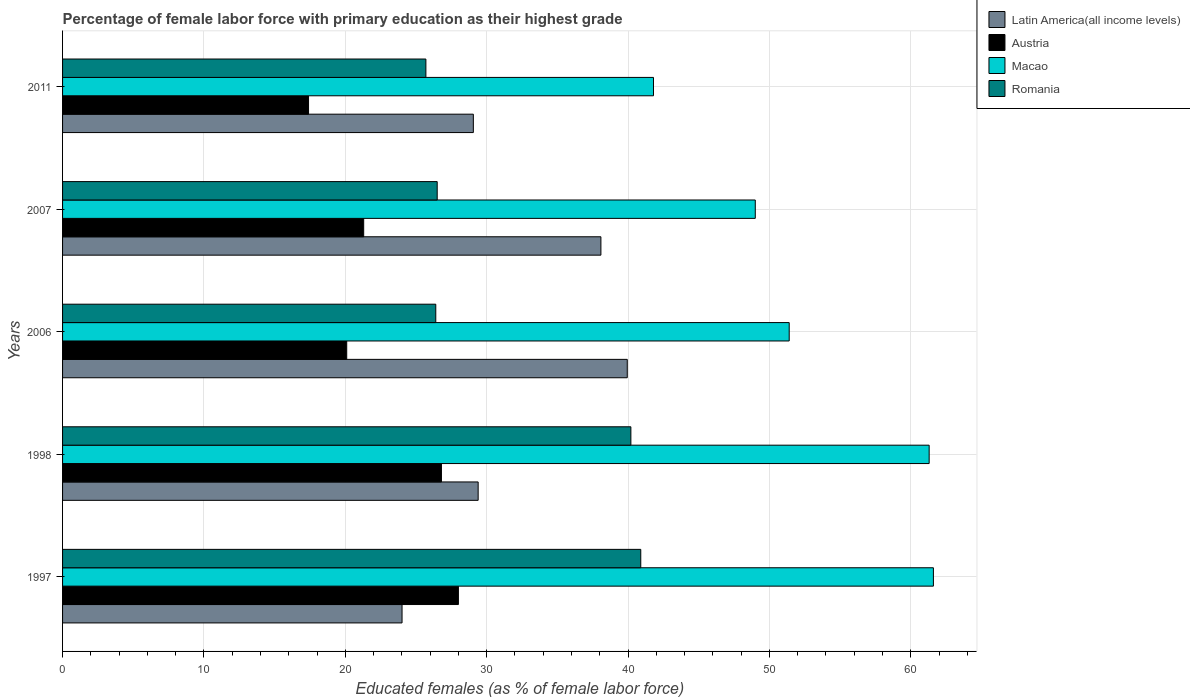Are the number of bars per tick equal to the number of legend labels?
Make the answer very short. Yes. Are the number of bars on each tick of the Y-axis equal?
Offer a terse response. Yes. How many bars are there on the 2nd tick from the bottom?
Make the answer very short. 4. What is the label of the 3rd group of bars from the top?
Keep it short and to the point. 2006. In how many cases, is the number of bars for a given year not equal to the number of legend labels?
Provide a succinct answer. 0. What is the percentage of female labor force with primary education in Austria in 1997?
Your response must be concise. 28. Across all years, what is the maximum percentage of female labor force with primary education in Latin America(all income levels)?
Provide a short and direct response. 39.95. Across all years, what is the minimum percentage of female labor force with primary education in Macao?
Keep it short and to the point. 41.8. What is the total percentage of female labor force with primary education in Macao in the graph?
Your response must be concise. 265.1. What is the difference between the percentage of female labor force with primary education in Macao in 1998 and that in 2006?
Provide a succinct answer. 9.9. What is the difference between the percentage of female labor force with primary education in Latin America(all income levels) in 2011 and the percentage of female labor force with primary education in Romania in 1997?
Provide a succinct answer. -11.84. What is the average percentage of female labor force with primary education in Macao per year?
Your response must be concise. 53.02. In the year 1997, what is the difference between the percentage of female labor force with primary education in Austria and percentage of female labor force with primary education in Latin America(all income levels)?
Provide a short and direct response. 3.99. What is the ratio of the percentage of female labor force with primary education in Austria in 2007 to that in 2011?
Provide a succinct answer. 1.22. Is the percentage of female labor force with primary education in Macao in 1997 less than that in 2006?
Your answer should be very brief. No. Is the difference between the percentage of female labor force with primary education in Austria in 1998 and 2006 greater than the difference between the percentage of female labor force with primary education in Latin America(all income levels) in 1998 and 2006?
Provide a short and direct response. Yes. What is the difference between the highest and the second highest percentage of female labor force with primary education in Latin America(all income levels)?
Offer a very short reply. 1.87. What is the difference between the highest and the lowest percentage of female labor force with primary education in Austria?
Ensure brevity in your answer.  10.6. What does the 2nd bar from the top in 2007 represents?
Provide a short and direct response. Macao. What does the 1st bar from the bottom in 2006 represents?
Offer a very short reply. Latin America(all income levels). Is it the case that in every year, the sum of the percentage of female labor force with primary education in Macao and percentage of female labor force with primary education in Romania is greater than the percentage of female labor force with primary education in Latin America(all income levels)?
Offer a very short reply. Yes. How many bars are there?
Your answer should be very brief. 20. Are all the bars in the graph horizontal?
Keep it short and to the point. Yes. How many years are there in the graph?
Your answer should be compact. 5. What is the difference between two consecutive major ticks on the X-axis?
Your answer should be very brief. 10. Does the graph contain any zero values?
Make the answer very short. No. Does the graph contain grids?
Your answer should be compact. Yes. Where does the legend appear in the graph?
Your answer should be compact. Top right. How are the legend labels stacked?
Your response must be concise. Vertical. What is the title of the graph?
Offer a terse response. Percentage of female labor force with primary education as their highest grade. Does "Paraguay" appear as one of the legend labels in the graph?
Give a very brief answer. No. What is the label or title of the X-axis?
Ensure brevity in your answer.  Educated females (as % of female labor force). What is the label or title of the Y-axis?
Give a very brief answer. Years. What is the Educated females (as % of female labor force) of Latin America(all income levels) in 1997?
Give a very brief answer. 24.01. What is the Educated females (as % of female labor force) in Macao in 1997?
Offer a very short reply. 61.6. What is the Educated females (as % of female labor force) in Romania in 1997?
Keep it short and to the point. 40.9. What is the Educated females (as % of female labor force) of Latin America(all income levels) in 1998?
Provide a succinct answer. 29.4. What is the Educated females (as % of female labor force) of Austria in 1998?
Provide a succinct answer. 26.8. What is the Educated females (as % of female labor force) in Macao in 1998?
Ensure brevity in your answer.  61.3. What is the Educated females (as % of female labor force) in Romania in 1998?
Your response must be concise. 40.2. What is the Educated females (as % of female labor force) of Latin America(all income levels) in 2006?
Your response must be concise. 39.95. What is the Educated females (as % of female labor force) in Austria in 2006?
Give a very brief answer. 20.1. What is the Educated females (as % of female labor force) of Macao in 2006?
Your response must be concise. 51.4. What is the Educated females (as % of female labor force) of Romania in 2006?
Keep it short and to the point. 26.4. What is the Educated females (as % of female labor force) of Latin America(all income levels) in 2007?
Give a very brief answer. 38.08. What is the Educated females (as % of female labor force) in Austria in 2007?
Provide a succinct answer. 21.3. What is the Educated females (as % of female labor force) of Macao in 2007?
Give a very brief answer. 49. What is the Educated females (as % of female labor force) of Latin America(all income levels) in 2011?
Ensure brevity in your answer.  29.06. What is the Educated females (as % of female labor force) in Austria in 2011?
Make the answer very short. 17.4. What is the Educated females (as % of female labor force) in Macao in 2011?
Offer a terse response. 41.8. What is the Educated females (as % of female labor force) of Romania in 2011?
Your answer should be compact. 25.7. Across all years, what is the maximum Educated females (as % of female labor force) of Latin America(all income levels)?
Keep it short and to the point. 39.95. Across all years, what is the maximum Educated females (as % of female labor force) in Austria?
Offer a very short reply. 28. Across all years, what is the maximum Educated females (as % of female labor force) in Macao?
Make the answer very short. 61.6. Across all years, what is the maximum Educated females (as % of female labor force) of Romania?
Ensure brevity in your answer.  40.9. Across all years, what is the minimum Educated females (as % of female labor force) in Latin America(all income levels)?
Give a very brief answer. 24.01. Across all years, what is the minimum Educated females (as % of female labor force) of Austria?
Provide a short and direct response. 17.4. Across all years, what is the minimum Educated females (as % of female labor force) of Macao?
Give a very brief answer. 41.8. Across all years, what is the minimum Educated females (as % of female labor force) in Romania?
Offer a terse response. 25.7. What is the total Educated females (as % of female labor force) in Latin America(all income levels) in the graph?
Make the answer very short. 160.49. What is the total Educated females (as % of female labor force) of Austria in the graph?
Your response must be concise. 113.6. What is the total Educated females (as % of female labor force) in Macao in the graph?
Provide a succinct answer. 265.1. What is the total Educated females (as % of female labor force) in Romania in the graph?
Offer a terse response. 159.7. What is the difference between the Educated females (as % of female labor force) of Latin America(all income levels) in 1997 and that in 1998?
Ensure brevity in your answer.  -5.38. What is the difference between the Educated females (as % of female labor force) in Macao in 1997 and that in 1998?
Ensure brevity in your answer.  0.3. What is the difference between the Educated females (as % of female labor force) in Romania in 1997 and that in 1998?
Offer a terse response. 0.7. What is the difference between the Educated females (as % of female labor force) in Latin America(all income levels) in 1997 and that in 2006?
Ensure brevity in your answer.  -15.93. What is the difference between the Educated females (as % of female labor force) of Macao in 1997 and that in 2006?
Offer a very short reply. 10.2. What is the difference between the Educated females (as % of female labor force) in Romania in 1997 and that in 2006?
Make the answer very short. 14.5. What is the difference between the Educated females (as % of female labor force) in Latin America(all income levels) in 1997 and that in 2007?
Make the answer very short. -14.07. What is the difference between the Educated females (as % of female labor force) in Austria in 1997 and that in 2007?
Your answer should be very brief. 6.7. What is the difference between the Educated females (as % of female labor force) of Romania in 1997 and that in 2007?
Make the answer very short. 14.4. What is the difference between the Educated females (as % of female labor force) in Latin America(all income levels) in 1997 and that in 2011?
Keep it short and to the point. -5.04. What is the difference between the Educated females (as % of female labor force) in Austria in 1997 and that in 2011?
Provide a short and direct response. 10.6. What is the difference between the Educated females (as % of female labor force) of Macao in 1997 and that in 2011?
Ensure brevity in your answer.  19.8. What is the difference between the Educated females (as % of female labor force) of Latin America(all income levels) in 1998 and that in 2006?
Ensure brevity in your answer.  -10.55. What is the difference between the Educated females (as % of female labor force) in Macao in 1998 and that in 2006?
Your answer should be very brief. 9.9. What is the difference between the Educated females (as % of female labor force) in Romania in 1998 and that in 2006?
Your answer should be compact. 13.8. What is the difference between the Educated females (as % of female labor force) in Latin America(all income levels) in 1998 and that in 2007?
Make the answer very short. -8.68. What is the difference between the Educated females (as % of female labor force) in Austria in 1998 and that in 2007?
Ensure brevity in your answer.  5.5. What is the difference between the Educated females (as % of female labor force) in Macao in 1998 and that in 2007?
Provide a short and direct response. 12.3. What is the difference between the Educated females (as % of female labor force) of Romania in 1998 and that in 2007?
Keep it short and to the point. 13.7. What is the difference between the Educated females (as % of female labor force) in Latin America(all income levels) in 1998 and that in 2011?
Your response must be concise. 0.34. What is the difference between the Educated females (as % of female labor force) in Austria in 1998 and that in 2011?
Keep it short and to the point. 9.4. What is the difference between the Educated females (as % of female labor force) of Macao in 1998 and that in 2011?
Your answer should be compact. 19.5. What is the difference between the Educated females (as % of female labor force) of Latin America(all income levels) in 2006 and that in 2007?
Give a very brief answer. 1.87. What is the difference between the Educated females (as % of female labor force) in Austria in 2006 and that in 2007?
Provide a succinct answer. -1.2. What is the difference between the Educated females (as % of female labor force) of Macao in 2006 and that in 2007?
Your response must be concise. 2.4. What is the difference between the Educated females (as % of female labor force) in Latin America(all income levels) in 2006 and that in 2011?
Your answer should be very brief. 10.89. What is the difference between the Educated females (as % of female labor force) of Austria in 2006 and that in 2011?
Keep it short and to the point. 2.7. What is the difference between the Educated females (as % of female labor force) in Macao in 2006 and that in 2011?
Your response must be concise. 9.6. What is the difference between the Educated females (as % of female labor force) of Latin America(all income levels) in 2007 and that in 2011?
Offer a terse response. 9.02. What is the difference between the Educated females (as % of female labor force) in Austria in 2007 and that in 2011?
Your answer should be compact. 3.9. What is the difference between the Educated females (as % of female labor force) of Latin America(all income levels) in 1997 and the Educated females (as % of female labor force) of Austria in 1998?
Offer a very short reply. -2.79. What is the difference between the Educated females (as % of female labor force) of Latin America(all income levels) in 1997 and the Educated females (as % of female labor force) of Macao in 1998?
Make the answer very short. -37.29. What is the difference between the Educated females (as % of female labor force) of Latin America(all income levels) in 1997 and the Educated females (as % of female labor force) of Romania in 1998?
Keep it short and to the point. -16.19. What is the difference between the Educated females (as % of female labor force) in Austria in 1997 and the Educated females (as % of female labor force) in Macao in 1998?
Offer a very short reply. -33.3. What is the difference between the Educated females (as % of female labor force) of Austria in 1997 and the Educated females (as % of female labor force) of Romania in 1998?
Your answer should be compact. -12.2. What is the difference between the Educated females (as % of female labor force) of Macao in 1997 and the Educated females (as % of female labor force) of Romania in 1998?
Your answer should be compact. 21.4. What is the difference between the Educated females (as % of female labor force) in Latin America(all income levels) in 1997 and the Educated females (as % of female labor force) in Austria in 2006?
Your answer should be very brief. 3.91. What is the difference between the Educated females (as % of female labor force) of Latin America(all income levels) in 1997 and the Educated females (as % of female labor force) of Macao in 2006?
Your response must be concise. -27.39. What is the difference between the Educated females (as % of female labor force) in Latin America(all income levels) in 1997 and the Educated females (as % of female labor force) in Romania in 2006?
Offer a very short reply. -2.39. What is the difference between the Educated females (as % of female labor force) in Austria in 1997 and the Educated females (as % of female labor force) in Macao in 2006?
Make the answer very short. -23.4. What is the difference between the Educated females (as % of female labor force) in Austria in 1997 and the Educated females (as % of female labor force) in Romania in 2006?
Provide a succinct answer. 1.6. What is the difference between the Educated females (as % of female labor force) of Macao in 1997 and the Educated females (as % of female labor force) of Romania in 2006?
Offer a very short reply. 35.2. What is the difference between the Educated females (as % of female labor force) of Latin America(all income levels) in 1997 and the Educated females (as % of female labor force) of Austria in 2007?
Offer a terse response. 2.71. What is the difference between the Educated females (as % of female labor force) of Latin America(all income levels) in 1997 and the Educated females (as % of female labor force) of Macao in 2007?
Provide a short and direct response. -24.99. What is the difference between the Educated females (as % of female labor force) in Latin America(all income levels) in 1997 and the Educated females (as % of female labor force) in Romania in 2007?
Offer a terse response. -2.49. What is the difference between the Educated females (as % of female labor force) of Austria in 1997 and the Educated females (as % of female labor force) of Macao in 2007?
Keep it short and to the point. -21. What is the difference between the Educated females (as % of female labor force) in Macao in 1997 and the Educated females (as % of female labor force) in Romania in 2007?
Provide a succinct answer. 35.1. What is the difference between the Educated females (as % of female labor force) of Latin America(all income levels) in 1997 and the Educated females (as % of female labor force) of Austria in 2011?
Offer a very short reply. 6.61. What is the difference between the Educated females (as % of female labor force) of Latin America(all income levels) in 1997 and the Educated females (as % of female labor force) of Macao in 2011?
Your answer should be compact. -17.79. What is the difference between the Educated females (as % of female labor force) in Latin America(all income levels) in 1997 and the Educated females (as % of female labor force) in Romania in 2011?
Provide a short and direct response. -1.69. What is the difference between the Educated females (as % of female labor force) of Austria in 1997 and the Educated females (as % of female labor force) of Macao in 2011?
Keep it short and to the point. -13.8. What is the difference between the Educated females (as % of female labor force) in Macao in 1997 and the Educated females (as % of female labor force) in Romania in 2011?
Offer a terse response. 35.9. What is the difference between the Educated females (as % of female labor force) of Latin America(all income levels) in 1998 and the Educated females (as % of female labor force) of Austria in 2006?
Offer a terse response. 9.3. What is the difference between the Educated females (as % of female labor force) in Latin America(all income levels) in 1998 and the Educated females (as % of female labor force) in Macao in 2006?
Ensure brevity in your answer.  -22. What is the difference between the Educated females (as % of female labor force) in Latin America(all income levels) in 1998 and the Educated females (as % of female labor force) in Romania in 2006?
Keep it short and to the point. 3. What is the difference between the Educated females (as % of female labor force) in Austria in 1998 and the Educated females (as % of female labor force) in Macao in 2006?
Your answer should be very brief. -24.6. What is the difference between the Educated females (as % of female labor force) of Austria in 1998 and the Educated females (as % of female labor force) of Romania in 2006?
Offer a very short reply. 0.4. What is the difference between the Educated females (as % of female labor force) of Macao in 1998 and the Educated females (as % of female labor force) of Romania in 2006?
Make the answer very short. 34.9. What is the difference between the Educated females (as % of female labor force) in Latin America(all income levels) in 1998 and the Educated females (as % of female labor force) in Austria in 2007?
Offer a terse response. 8.1. What is the difference between the Educated females (as % of female labor force) in Latin America(all income levels) in 1998 and the Educated females (as % of female labor force) in Macao in 2007?
Provide a short and direct response. -19.6. What is the difference between the Educated females (as % of female labor force) in Latin America(all income levels) in 1998 and the Educated females (as % of female labor force) in Romania in 2007?
Your answer should be compact. 2.9. What is the difference between the Educated females (as % of female labor force) of Austria in 1998 and the Educated females (as % of female labor force) of Macao in 2007?
Offer a very short reply. -22.2. What is the difference between the Educated females (as % of female labor force) of Macao in 1998 and the Educated females (as % of female labor force) of Romania in 2007?
Make the answer very short. 34.8. What is the difference between the Educated females (as % of female labor force) of Latin America(all income levels) in 1998 and the Educated females (as % of female labor force) of Austria in 2011?
Provide a succinct answer. 12. What is the difference between the Educated females (as % of female labor force) in Latin America(all income levels) in 1998 and the Educated females (as % of female labor force) in Macao in 2011?
Provide a succinct answer. -12.4. What is the difference between the Educated females (as % of female labor force) of Latin America(all income levels) in 1998 and the Educated females (as % of female labor force) of Romania in 2011?
Offer a very short reply. 3.7. What is the difference between the Educated females (as % of female labor force) in Austria in 1998 and the Educated females (as % of female labor force) in Romania in 2011?
Ensure brevity in your answer.  1.1. What is the difference between the Educated females (as % of female labor force) of Macao in 1998 and the Educated females (as % of female labor force) of Romania in 2011?
Give a very brief answer. 35.6. What is the difference between the Educated females (as % of female labor force) in Latin America(all income levels) in 2006 and the Educated females (as % of female labor force) in Austria in 2007?
Offer a terse response. 18.65. What is the difference between the Educated females (as % of female labor force) in Latin America(all income levels) in 2006 and the Educated females (as % of female labor force) in Macao in 2007?
Offer a terse response. -9.05. What is the difference between the Educated females (as % of female labor force) of Latin America(all income levels) in 2006 and the Educated females (as % of female labor force) of Romania in 2007?
Make the answer very short. 13.45. What is the difference between the Educated females (as % of female labor force) in Austria in 2006 and the Educated females (as % of female labor force) in Macao in 2007?
Give a very brief answer. -28.9. What is the difference between the Educated females (as % of female labor force) in Macao in 2006 and the Educated females (as % of female labor force) in Romania in 2007?
Your response must be concise. 24.9. What is the difference between the Educated females (as % of female labor force) of Latin America(all income levels) in 2006 and the Educated females (as % of female labor force) of Austria in 2011?
Make the answer very short. 22.55. What is the difference between the Educated females (as % of female labor force) of Latin America(all income levels) in 2006 and the Educated females (as % of female labor force) of Macao in 2011?
Ensure brevity in your answer.  -1.85. What is the difference between the Educated females (as % of female labor force) in Latin America(all income levels) in 2006 and the Educated females (as % of female labor force) in Romania in 2011?
Your answer should be very brief. 14.25. What is the difference between the Educated females (as % of female labor force) of Austria in 2006 and the Educated females (as % of female labor force) of Macao in 2011?
Keep it short and to the point. -21.7. What is the difference between the Educated females (as % of female labor force) of Austria in 2006 and the Educated females (as % of female labor force) of Romania in 2011?
Your answer should be very brief. -5.6. What is the difference between the Educated females (as % of female labor force) of Macao in 2006 and the Educated females (as % of female labor force) of Romania in 2011?
Your answer should be compact. 25.7. What is the difference between the Educated females (as % of female labor force) of Latin America(all income levels) in 2007 and the Educated females (as % of female labor force) of Austria in 2011?
Keep it short and to the point. 20.68. What is the difference between the Educated females (as % of female labor force) in Latin America(all income levels) in 2007 and the Educated females (as % of female labor force) in Macao in 2011?
Your response must be concise. -3.72. What is the difference between the Educated females (as % of female labor force) of Latin America(all income levels) in 2007 and the Educated females (as % of female labor force) of Romania in 2011?
Provide a short and direct response. 12.38. What is the difference between the Educated females (as % of female labor force) in Austria in 2007 and the Educated females (as % of female labor force) in Macao in 2011?
Ensure brevity in your answer.  -20.5. What is the difference between the Educated females (as % of female labor force) in Austria in 2007 and the Educated females (as % of female labor force) in Romania in 2011?
Provide a succinct answer. -4.4. What is the difference between the Educated females (as % of female labor force) in Macao in 2007 and the Educated females (as % of female labor force) in Romania in 2011?
Ensure brevity in your answer.  23.3. What is the average Educated females (as % of female labor force) in Latin America(all income levels) per year?
Your answer should be compact. 32.1. What is the average Educated females (as % of female labor force) in Austria per year?
Make the answer very short. 22.72. What is the average Educated females (as % of female labor force) of Macao per year?
Keep it short and to the point. 53.02. What is the average Educated females (as % of female labor force) of Romania per year?
Make the answer very short. 31.94. In the year 1997, what is the difference between the Educated females (as % of female labor force) of Latin America(all income levels) and Educated females (as % of female labor force) of Austria?
Your response must be concise. -3.99. In the year 1997, what is the difference between the Educated females (as % of female labor force) of Latin America(all income levels) and Educated females (as % of female labor force) of Macao?
Your answer should be very brief. -37.59. In the year 1997, what is the difference between the Educated females (as % of female labor force) in Latin America(all income levels) and Educated females (as % of female labor force) in Romania?
Offer a terse response. -16.89. In the year 1997, what is the difference between the Educated females (as % of female labor force) in Austria and Educated females (as % of female labor force) in Macao?
Provide a short and direct response. -33.6. In the year 1997, what is the difference between the Educated females (as % of female labor force) in Austria and Educated females (as % of female labor force) in Romania?
Your response must be concise. -12.9. In the year 1997, what is the difference between the Educated females (as % of female labor force) of Macao and Educated females (as % of female labor force) of Romania?
Offer a terse response. 20.7. In the year 1998, what is the difference between the Educated females (as % of female labor force) of Latin America(all income levels) and Educated females (as % of female labor force) of Austria?
Give a very brief answer. 2.6. In the year 1998, what is the difference between the Educated females (as % of female labor force) in Latin America(all income levels) and Educated females (as % of female labor force) in Macao?
Ensure brevity in your answer.  -31.9. In the year 1998, what is the difference between the Educated females (as % of female labor force) in Latin America(all income levels) and Educated females (as % of female labor force) in Romania?
Make the answer very short. -10.8. In the year 1998, what is the difference between the Educated females (as % of female labor force) in Austria and Educated females (as % of female labor force) in Macao?
Your answer should be compact. -34.5. In the year 1998, what is the difference between the Educated females (as % of female labor force) of Macao and Educated females (as % of female labor force) of Romania?
Give a very brief answer. 21.1. In the year 2006, what is the difference between the Educated females (as % of female labor force) in Latin America(all income levels) and Educated females (as % of female labor force) in Austria?
Ensure brevity in your answer.  19.85. In the year 2006, what is the difference between the Educated females (as % of female labor force) in Latin America(all income levels) and Educated females (as % of female labor force) in Macao?
Provide a succinct answer. -11.45. In the year 2006, what is the difference between the Educated females (as % of female labor force) in Latin America(all income levels) and Educated females (as % of female labor force) in Romania?
Give a very brief answer. 13.55. In the year 2006, what is the difference between the Educated females (as % of female labor force) in Austria and Educated females (as % of female labor force) in Macao?
Make the answer very short. -31.3. In the year 2006, what is the difference between the Educated females (as % of female labor force) of Macao and Educated females (as % of female labor force) of Romania?
Give a very brief answer. 25. In the year 2007, what is the difference between the Educated females (as % of female labor force) of Latin America(all income levels) and Educated females (as % of female labor force) of Austria?
Offer a terse response. 16.78. In the year 2007, what is the difference between the Educated females (as % of female labor force) of Latin America(all income levels) and Educated females (as % of female labor force) of Macao?
Your response must be concise. -10.92. In the year 2007, what is the difference between the Educated females (as % of female labor force) in Latin America(all income levels) and Educated females (as % of female labor force) in Romania?
Provide a succinct answer. 11.58. In the year 2007, what is the difference between the Educated females (as % of female labor force) of Austria and Educated females (as % of female labor force) of Macao?
Provide a succinct answer. -27.7. In the year 2007, what is the difference between the Educated females (as % of female labor force) in Macao and Educated females (as % of female labor force) in Romania?
Provide a short and direct response. 22.5. In the year 2011, what is the difference between the Educated females (as % of female labor force) in Latin America(all income levels) and Educated females (as % of female labor force) in Austria?
Provide a succinct answer. 11.66. In the year 2011, what is the difference between the Educated females (as % of female labor force) of Latin America(all income levels) and Educated females (as % of female labor force) of Macao?
Offer a terse response. -12.74. In the year 2011, what is the difference between the Educated females (as % of female labor force) of Latin America(all income levels) and Educated females (as % of female labor force) of Romania?
Your answer should be very brief. 3.36. In the year 2011, what is the difference between the Educated females (as % of female labor force) of Austria and Educated females (as % of female labor force) of Macao?
Offer a very short reply. -24.4. In the year 2011, what is the difference between the Educated females (as % of female labor force) of Macao and Educated females (as % of female labor force) of Romania?
Give a very brief answer. 16.1. What is the ratio of the Educated females (as % of female labor force) in Latin America(all income levels) in 1997 to that in 1998?
Ensure brevity in your answer.  0.82. What is the ratio of the Educated females (as % of female labor force) of Austria in 1997 to that in 1998?
Offer a very short reply. 1.04. What is the ratio of the Educated females (as % of female labor force) of Macao in 1997 to that in 1998?
Ensure brevity in your answer.  1. What is the ratio of the Educated females (as % of female labor force) of Romania in 1997 to that in 1998?
Your answer should be compact. 1.02. What is the ratio of the Educated females (as % of female labor force) of Latin America(all income levels) in 1997 to that in 2006?
Your answer should be compact. 0.6. What is the ratio of the Educated females (as % of female labor force) of Austria in 1997 to that in 2006?
Your response must be concise. 1.39. What is the ratio of the Educated females (as % of female labor force) in Macao in 1997 to that in 2006?
Ensure brevity in your answer.  1.2. What is the ratio of the Educated females (as % of female labor force) of Romania in 1997 to that in 2006?
Your answer should be compact. 1.55. What is the ratio of the Educated females (as % of female labor force) of Latin America(all income levels) in 1997 to that in 2007?
Your response must be concise. 0.63. What is the ratio of the Educated females (as % of female labor force) of Austria in 1997 to that in 2007?
Your answer should be compact. 1.31. What is the ratio of the Educated females (as % of female labor force) in Macao in 1997 to that in 2007?
Your answer should be very brief. 1.26. What is the ratio of the Educated females (as % of female labor force) of Romania in 1997 to that in 2007?
Provide a succinct answer. 1.54. What is the ratio of the Educated females (as % of female labor force) in Latin America(all income levels) in 1997 to that in 2011?
Ensure brevity in your answer.  0.83. What is the ratio of the Educated females (as % of female labor force) in Austria in 1997 to that in 2011?
Provide a short and direct response. 1.61. What is the ratio of the Educated females (as % of female labor force) in Macao in 1997 to that in 2011?
Your answer should be compact. 1.47. What is the ratio of the Educated females (as % of female labor force) in Romania in 1997 to that in 2011?
Your response must be concise. 1.59. What is the ratio of the Educated females (as % of female labor force) in Latin America(all income levels) in 1998 to that in 2006?
Provide a short and direct response. 0.74. What is the ratio of the Educated females (as % of female labor force) of Macao in 1998 to that in 2006?
Give a very brief answer. 1.19. What is the ratio of the Educated females (as % of female labor force) of Romania in 1998 to that in 2006?
Provide a short and direct response. 1.52. What is the ratio of the Educated females (as % of female labor force) in Latin America(all income levels) in 1998 to that in 2007?
Provide a short and direct response. 0.77. What is the ratio of the Educated females (as % of female labor force) in Austria in 1998 to that in 2007?
Provide a succinct answer. 1.26. What is the ratio of the Educated females (as % of female labor force) in Macao in 1998 to that in 2007?
Your answer should be very brief. 1.25. What is the ratio of the Educated females (as % of female labor force) in Romania in 1998 to that in 2007?
Keep it short and to the point. 1.52. What is the ratio of the Educated females (as % of female labor force) in Latin America(all income levels) in 1998 to that in 2011?
Your answer should be compact. 1.01. What is the ratio of the Educated females (as % of female labor force) of Austria in 1998 to that in 2011?
Give a very brief answer. 1.54. What is the ratio of the Educated females (as % of female labor force) of Macao in 1998 to that in 2011?
Your answer should be compact. 1.47. What is the ratio of the Educated females (as % of female labor force) in Romania in 1998 to that in 2011?
Your answer should be very brief. 1.56. What is the ratio of the Educated females (as % of female labor force) in Latin America(all income levels) in 2006 to that in 2007?
Your answer should be very brief. 1.05. What is the ratio of the Educated females (as % of female labor force) in Austria in 2006 to that in 2007?
Keep it short and to the point. 0.94. What is the ratio of the Educated females (as % of female labor force) in Macao in 2006 to that in 2007?
Ensure brevity in your answer.  1.05. What is the ratio of the Educated females (as % of female labor force) of Latin America(all income levels) in 2006 to that in 2011?
Provide a short and direct response. 1.37. What is the ratio of the Educated females (as % of female labor force) in Austria in 2006 to that in 2011?
Offer a very short reply. 1.16. What is the ratio of the Educated females (as % of female labor force) of Macao in 2006 to that in 2011?
Your answer should be compact. 1.23. What is the ratio of the Educated females (as % of female labor force) of Romania in 2006 to that in 2011?
Make the answer very short. 1.03. What is the ratio of the Educated females (as % of female labor force) in Latin America(all income levels) in 2007 to that in 2011?
Your answer should be compact. 1.31. What is the ratio of the Educated females (as % of female labor force) of Austria in 2007 to that in 2011?
Your response must be concise. 1.22. What is the ratio of the Educated females (as % of female labor force) of Macao in 2007 to that in 2011?
Give a very brief answer. 1.17. What is the ratio of the Educated females (as % of female labor force) in Romania in 2007 to that in 2011?
Your response must be concise. 1.03. What is the difference between the highest and the second highest Educated females (as % of female labor force) in Latin America(all income levels)?
Make the answer very short. 1.87. What is the difference between the highest and the second highest Educated females (as % of female labor force) of Macao?
Ensure brevity in your answer.  0.3. What is the difference between the highest and the second highest Educated females (as % of female labor force) of Romania?
Provide a short and direct response. 0.7. What is the difference between the highest and the lowest Educated females (as % of female labor force) of Latin America(all income levels)?
Your answer should be compact. 15.93. What is the difference between the highest and the lowest Educated females (as % of female labor force) in Macao?
Your answer should be very brief. 19.8. 